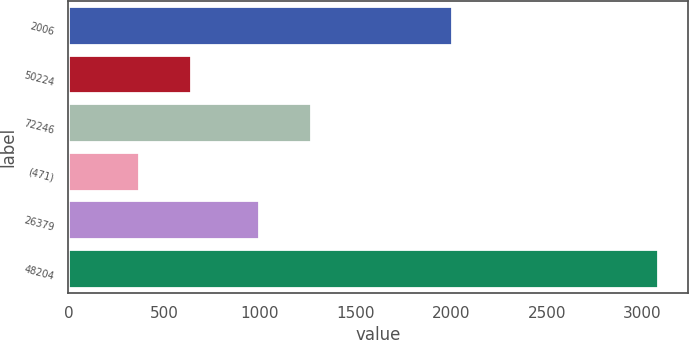Convert chart. <chart><loc_0><loc_0><loc_500><loc_500><bar_chart><fcel>2006<fcel>50224<fcel>72246<fcel>(471)<fcel>26379<fcel>48204<nl><fcel>2004<fcel>642.2<fcel>1267.2<fcel>371<fcel>996<fcel>3083<nl></chart> 